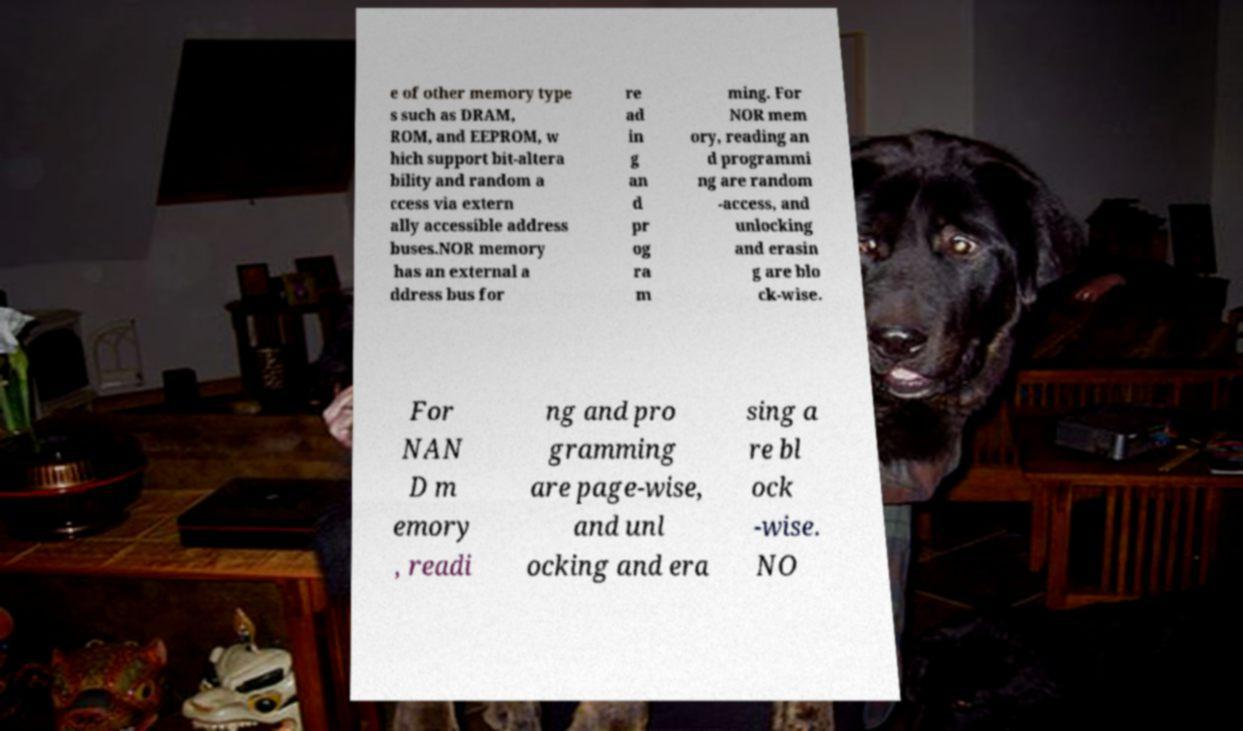I need the written content from this picture converted into text. Can you do that? e of other memory type s such as DRAM, ROM, and EEPROM, w hich support bit-altera bility and random a ccess via extern ally accessible address buses.NOR memory has an external a ddress bus for re ad in g an d pr og ra m ming. For NOR mem ory, reading an d programmi ng are random -access, and unlocking and erasin g are blo ck-wise. For NAN D m emory , readi ng and pro gramming are page-wise, and unl ocking and era sing a re bl ock -wise. NO 